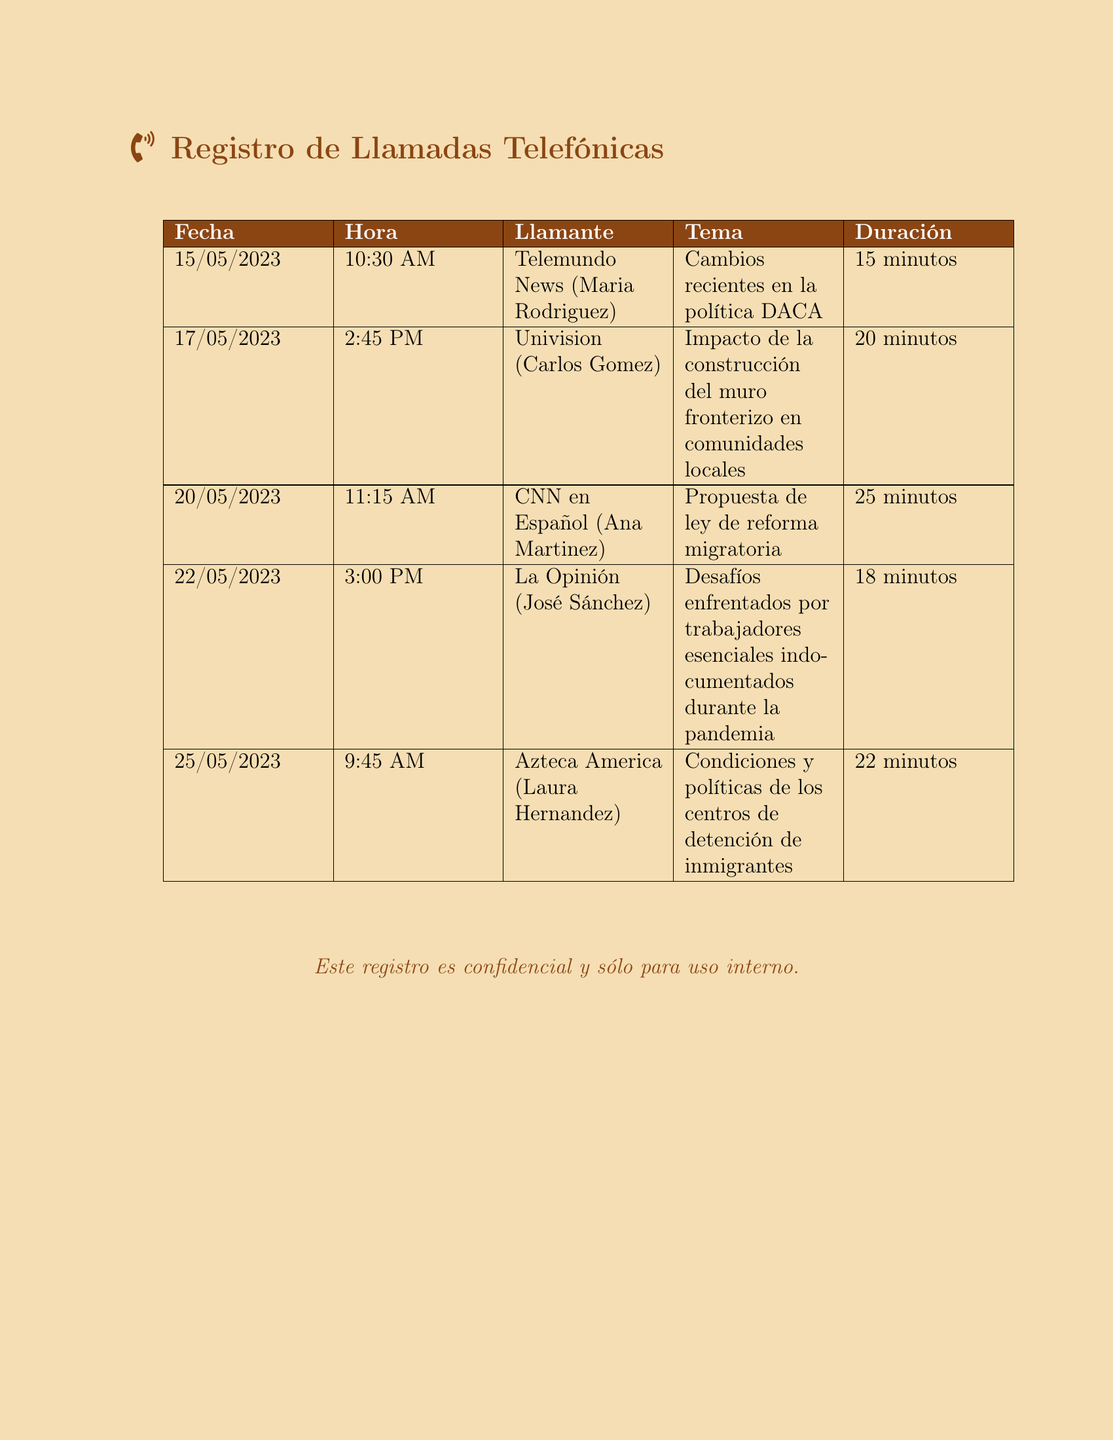¿Cuál fue la duración de la llamada con CNN en Español? La duración de la llamada se encuentra en la columna correspondiente, que indica 25 minutos.
Answer: 25 minutos ¿Quién llamó el 22 de mayo de 2023? El nombre del llamante se puede encontrar en la primera columna junto con la fecha, que es José Sánchez.
Answer: José Sánchez ¿Qué tema fue discutido en la llamada con Univision? El tema se menciona en la columna correspondiente, que es el impacto de la construcción del muro fronterizo en comunidades locales.
Answer: Impacto de la construcción del muro fronterizo en comunidades locales ¿Cuántas llamadas se registraron en total? El total de registros se cuenta en la tabla, que contiene 5 filas de llamadas.
Answer: 5 ¿Cuál es la duración promedio de las llamadas en este registro? La duración promedio se calcula sumando la duración de cada llamada y dividiendo por el número de llamadas, que da aproximadamente 18 minutos.
Answer: 18 minutos ¿Qué medio de comunicación hizo la primera llamada? La primera llamada se puede identificar al observar la primera fila de la tabla, que es Telemundo News.
Answer: Telemundo News ¿Cuál fue el último tema tratado en este registro? El último tema se encuentra en la última fila de la tabla, sobre las condiciones de los centros de detención.
Answer: Condiciones y políticas de los centros de detención de inmigrantes ¿En qué fecha se realizó la llamada sobre la reforma migratoria? La fecha de esta llamada se menciona en la tabla, que es el 20 de mayo de 2023.
Answer: 20/05/2023 ¿Qué se puede inferir sobre el enfoque de los medios en estas llamadas? La temática de las llamadas se agrupa principalmente en cuestiones de políticas migratorias y derechos de los inmigrantes, sugiriendo un enfoque en estos temas relevantes.
Answer: Políticas migratorias y derechos de los inmigrantes 